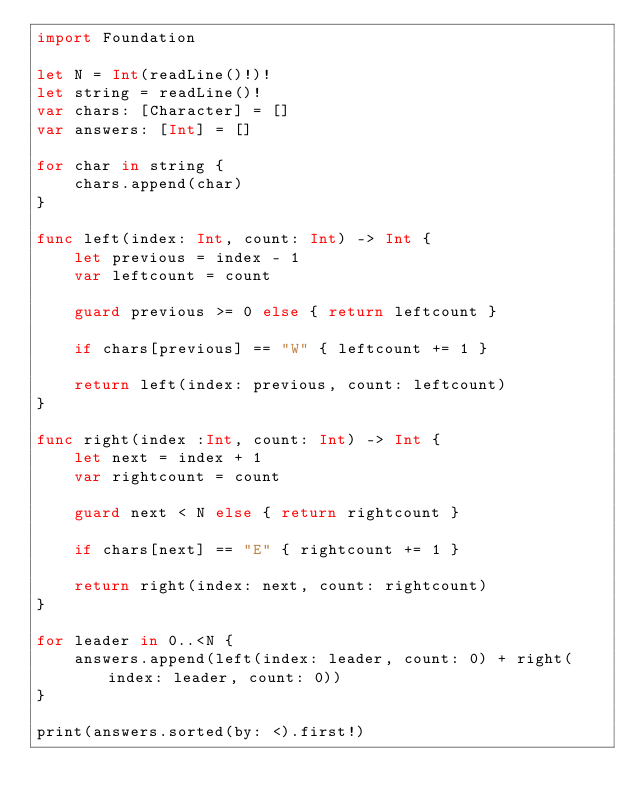Convert code to text. <code><loc_0><loc_0><loc_500><loc_500><_Swift_>import Foundation

let N = Int(readLine()!)!
let string = readLine()!
var chars: [Character] = []
var answers: [Int] = []

for char in string {
    chars.append(char)
}

func left(index: Int, count: Int) -> Int {
    let previous = index - 1
    var leftcount = count
    
    guard previous >= 0 else { return leftcount }
    
    if chars[previous] == "W" { leftcount += 1 }

    return left(index: previous, count: leftcount)
}

func right(index :Int, count: Int) -> Int {
    let next = index + 1
    var rightcount = count
    
    guard next < N else { return rightcount }
    
    if chars[next] == "E" { rightcount += 1 }
    
    return right(index: next, count: rightcount)
}

for leader in 0..<N {
    answers.append(left(index: leader, count: 0) + right(index: leader, count: 0))
}

print(answers.sorted(by: <).first!)
</code> 